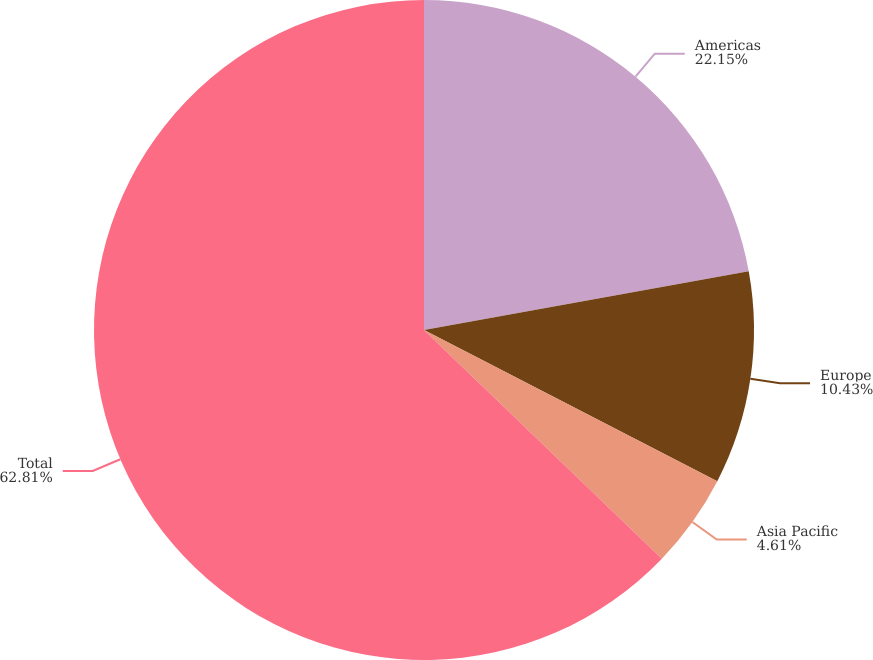Convert chart to OTSL. <chart><loc_0><loc_0><loc_500><loc_500><pie_chart><fcel>Americas<fcel>Europe<fcel>Asia Pacific<fcel>Total<nl><fcel>22.15%<fcel>10.43%<fcel>4.61%<fcel>62.81%<nl></chart> 